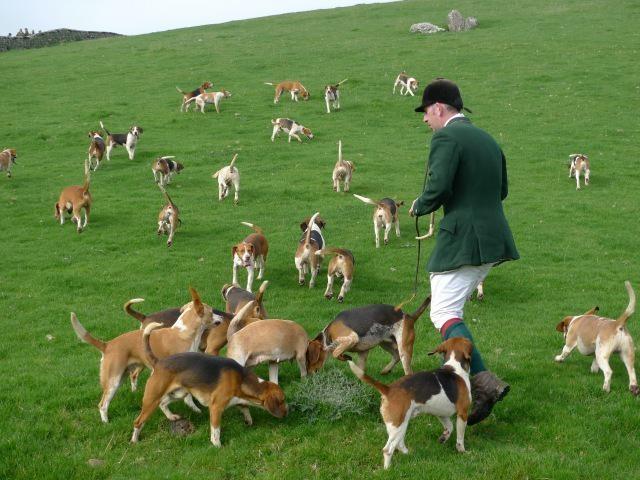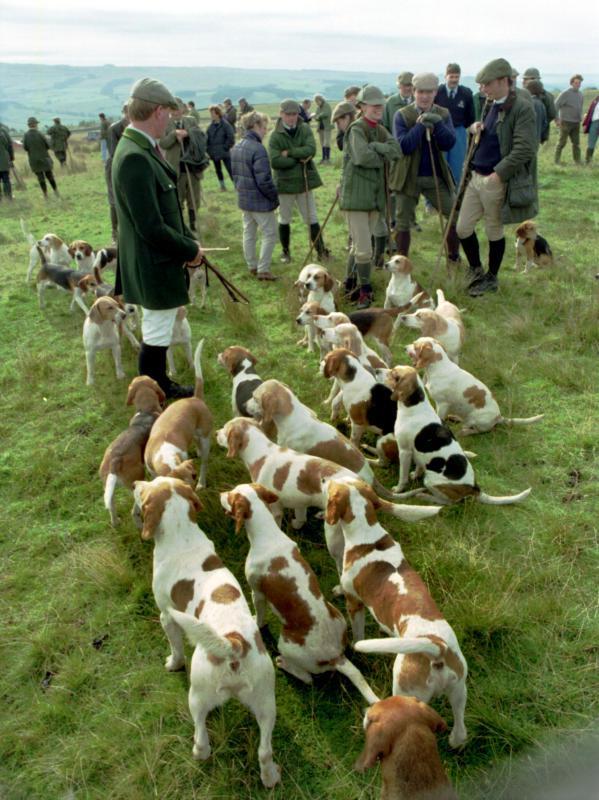The first image is the image on the left, the second image is the image on the right. Evaluate the accuracy of this statement regarding the images: "An image shows multiple men in blazers, caps and tall socks over pants standing near a pack of hounds.". Is it true? Answer yes or no. Yes. 